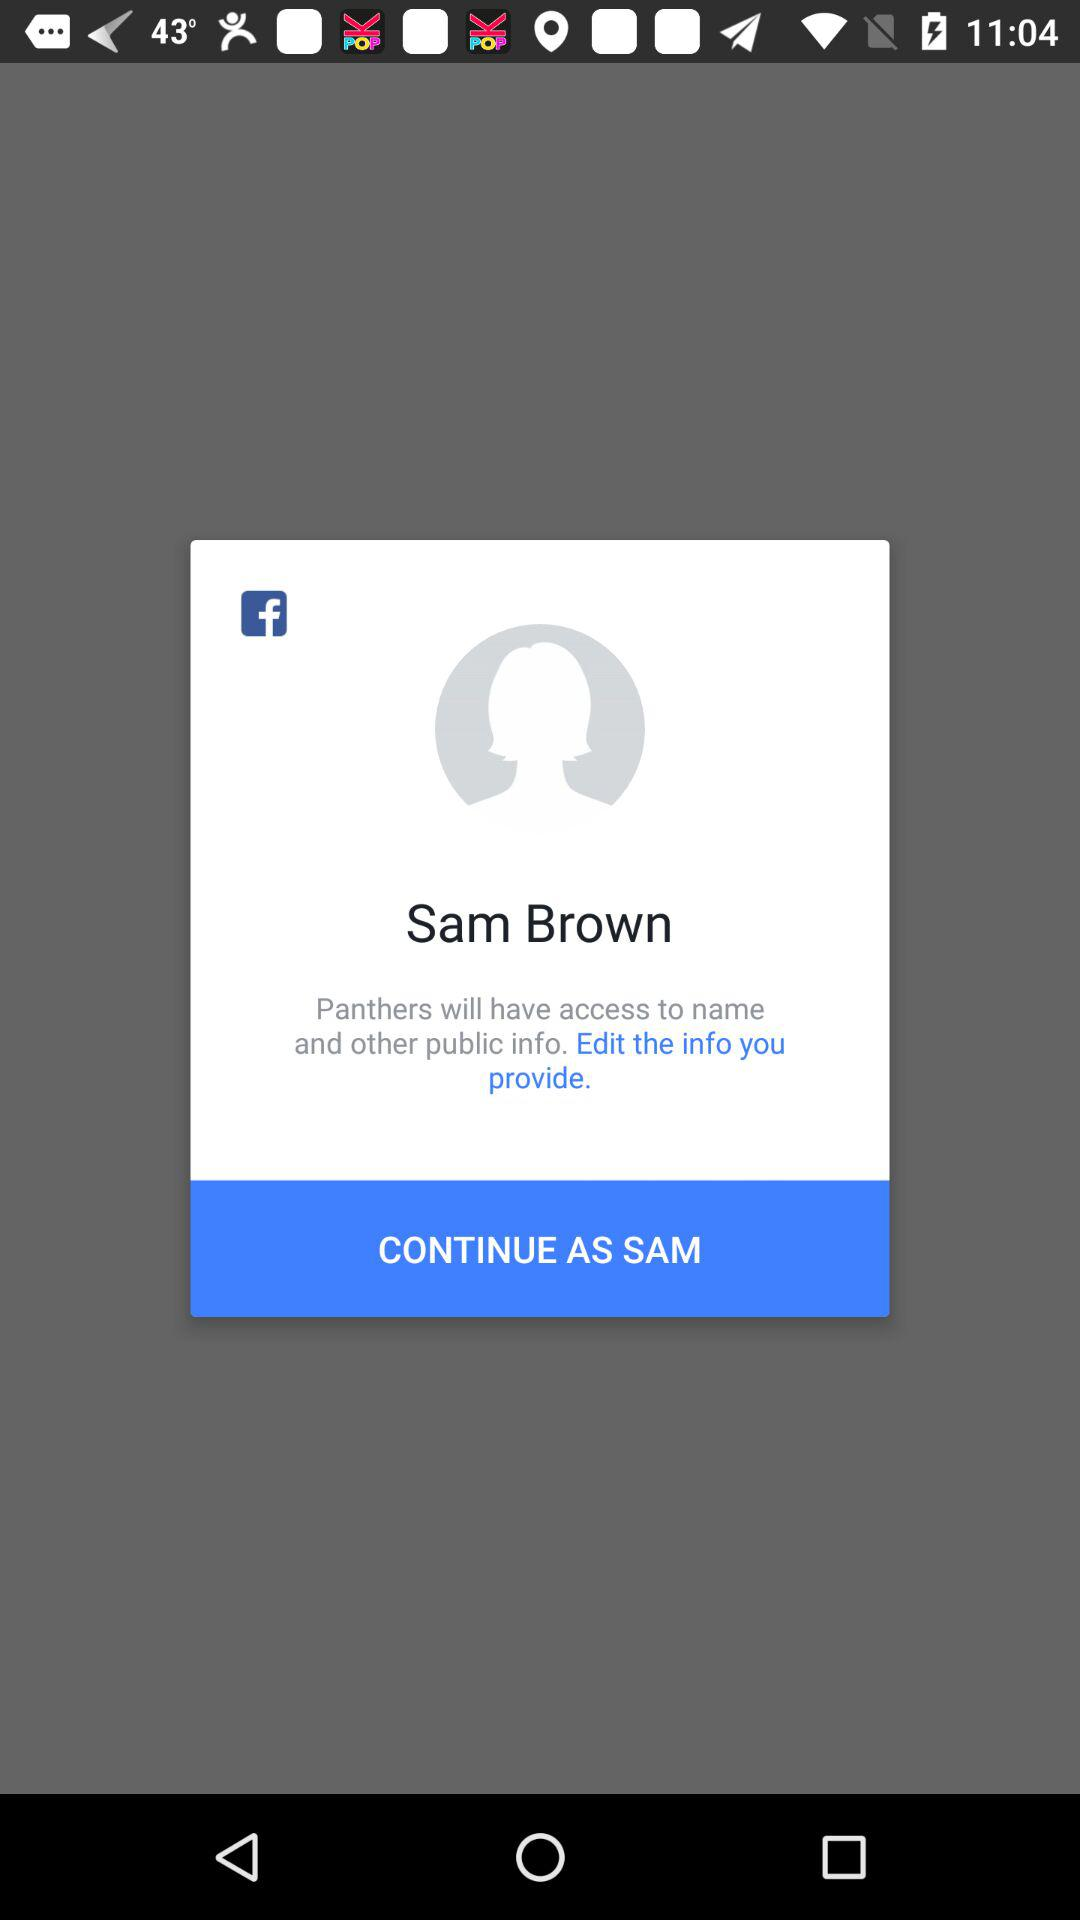What application is asking for permission? The application asking for permission is "Panthers". 